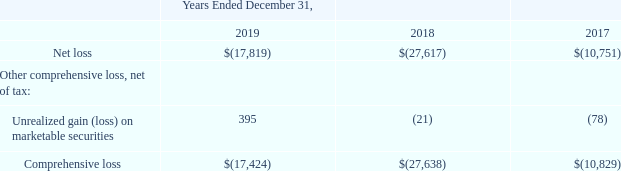A10 NETWORKS, INC.
CONSOLIDATED STATEMENTS OF COMPREHENSIVE LOSS
(in thousands)
What is the units used to describe the data in the table? In thousands. What is the name of the table that the data is extracted from? Consolidated statements of comprehensive loss. What is the company's net loss in 2019?
Answer scale should be: thousand. $(17,819). What is the company's percentage change in net loss between 2018 and 2019?
Answer scale should be: percent. ($(-17,424)-$(-27,638))/$(-27,638) 
Answer: -36.96. What is the company's total unrealized gain on marketable securities between 2017 to 2019?
Answer scale should be: thousand. 395+(-21)+(-78) 
Answer: 296. What is the company's total Comprehensive loss between 2017 to 2019?
Answer scale should be: thousand. $(-17,424)+$(-27,638)+$(-10,829)
Answer: -55891. 